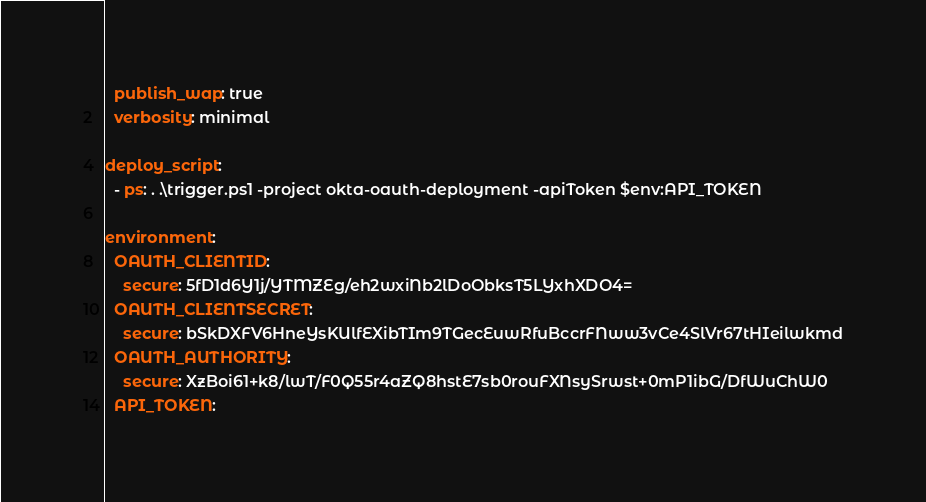<code> <loc_0><loc_0><loc_500><loc_500><_YAML_>  publish_wap: true
  verbosity: minimal

deploy_script:
  - ps: . .\trigger.ps1 -project okta-oauth-deployment -apiToken $env:API_TOKEN

environment:
  OAUTH_CLIENTID:
    secure: 5fD1d6Y1j/YTMZEg/eh2wxiNb2lDoObksT5LYxhXDO4=
  OAUTH_CLIENTSECRET:
    secure: bSkDXFV6HneYsKUlfEXibTIm9TGecEuwRfuBccrFNww3vCe4SlVr67tHIeilwkmd
  OAUTH_AUTHORITY:
    secure: XzBoi61+k8/lwT/F0Q55r4aZQ8hstE7sb0rouFXNsySrwst+0mP1ibG/DfWuChW0
  API_TOKEN:</code> 